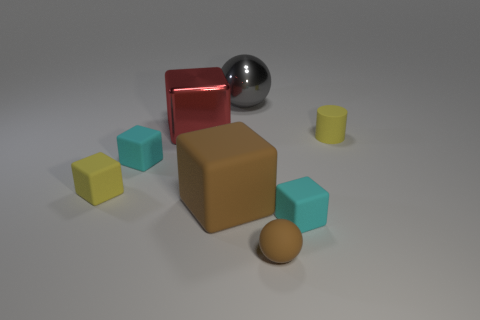What number of large brown blocks are made of the same material as the small yellow block?
Make the answer very short. 1. Does the yellow matte cylinder have the same size as the yellow block?
Your response must be concise. Yes. Is there any other thing that has the same color as the large matte thing?
Provide a succinct answer. Yes. The large thing that is both behind the big brown rubber thing and to the left of the metallic ball has what shape?
Provide a succinct answer. Cube. There is a cyan rubber block that is to the left of the large red cube; how big is it?
Offer a very short reply. Small. There is a cyan object that is behind the cyan object that is on the right side of the gray thing; how many yellow matte things are left of it?
Give a very brief answer. 1. There is a large red cube; are there any shiny things behind it?
Make the answer very short. Yes. What number of other things are the same size as the brown rubber ball?
Keep it short and to the point. 4. There is a tiny block that is to the right of the yellow rubber cube and on the left side of the big red object; what material is it?
Keep it short and to the point. Rubber. Is the shape of the brown rubber object that is in front of the big rubber object the same as the brown rubber object that is behind the tiny brown sphere?
Offer a terse response. No. 